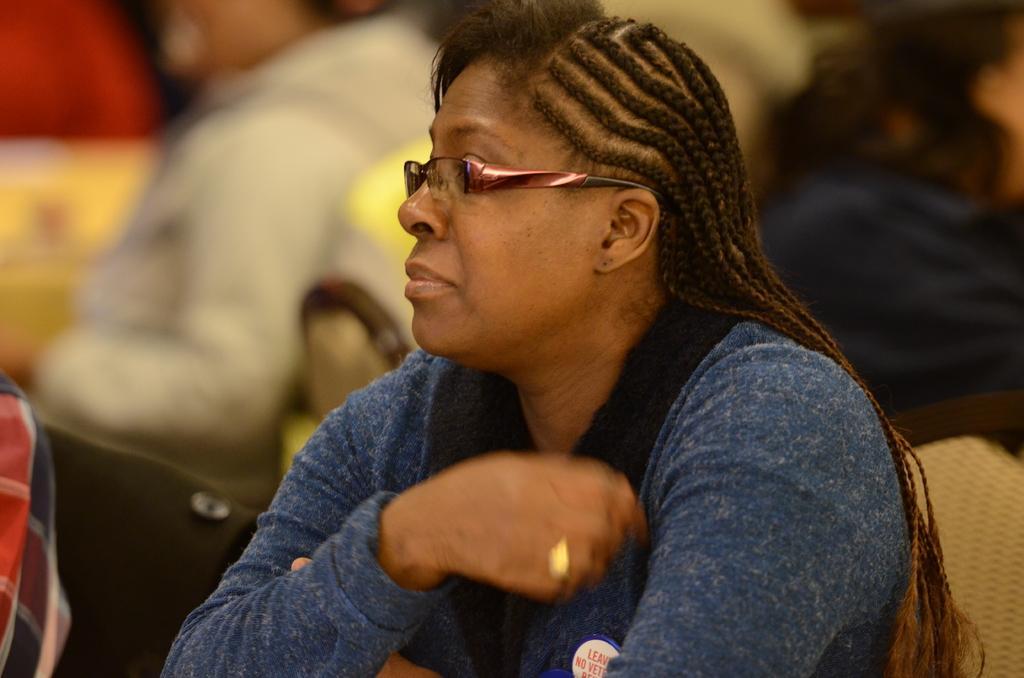Please provide a concise description of this image. Here we can see a woman is sitting on a chair. In the background the image is blur but we can see few persons are sitting on the chairs. 